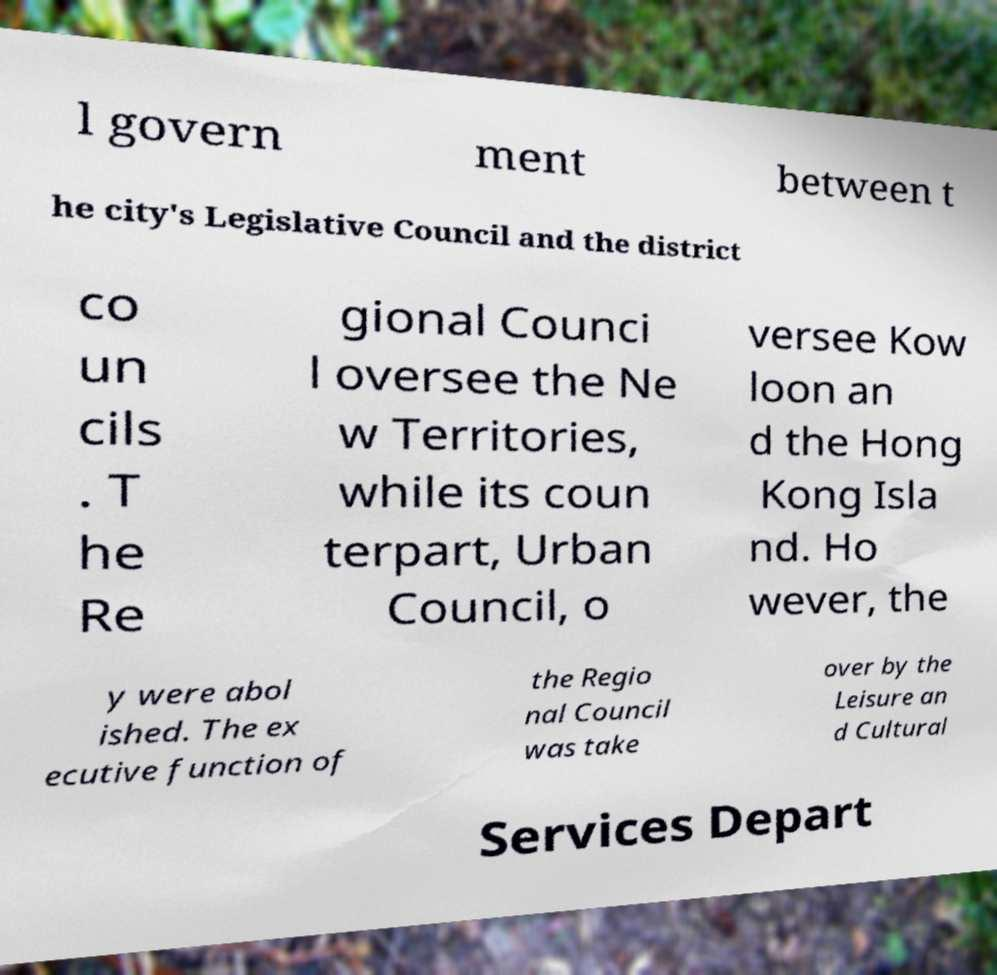Could you extract and type out the text from this image? l govern ment between t he city's Legislative Council and the district co un cils . T he Re gional Counci l oversee the Ne w Territories, while its coun terpart, Urban Council, o versee Kow loon an d the Hong Kong Isla nd. Ho wever, the y were abol ished. The ex ecutive function of the Regio nal Council was take over by the Leisure an d Cultural Services Depart 